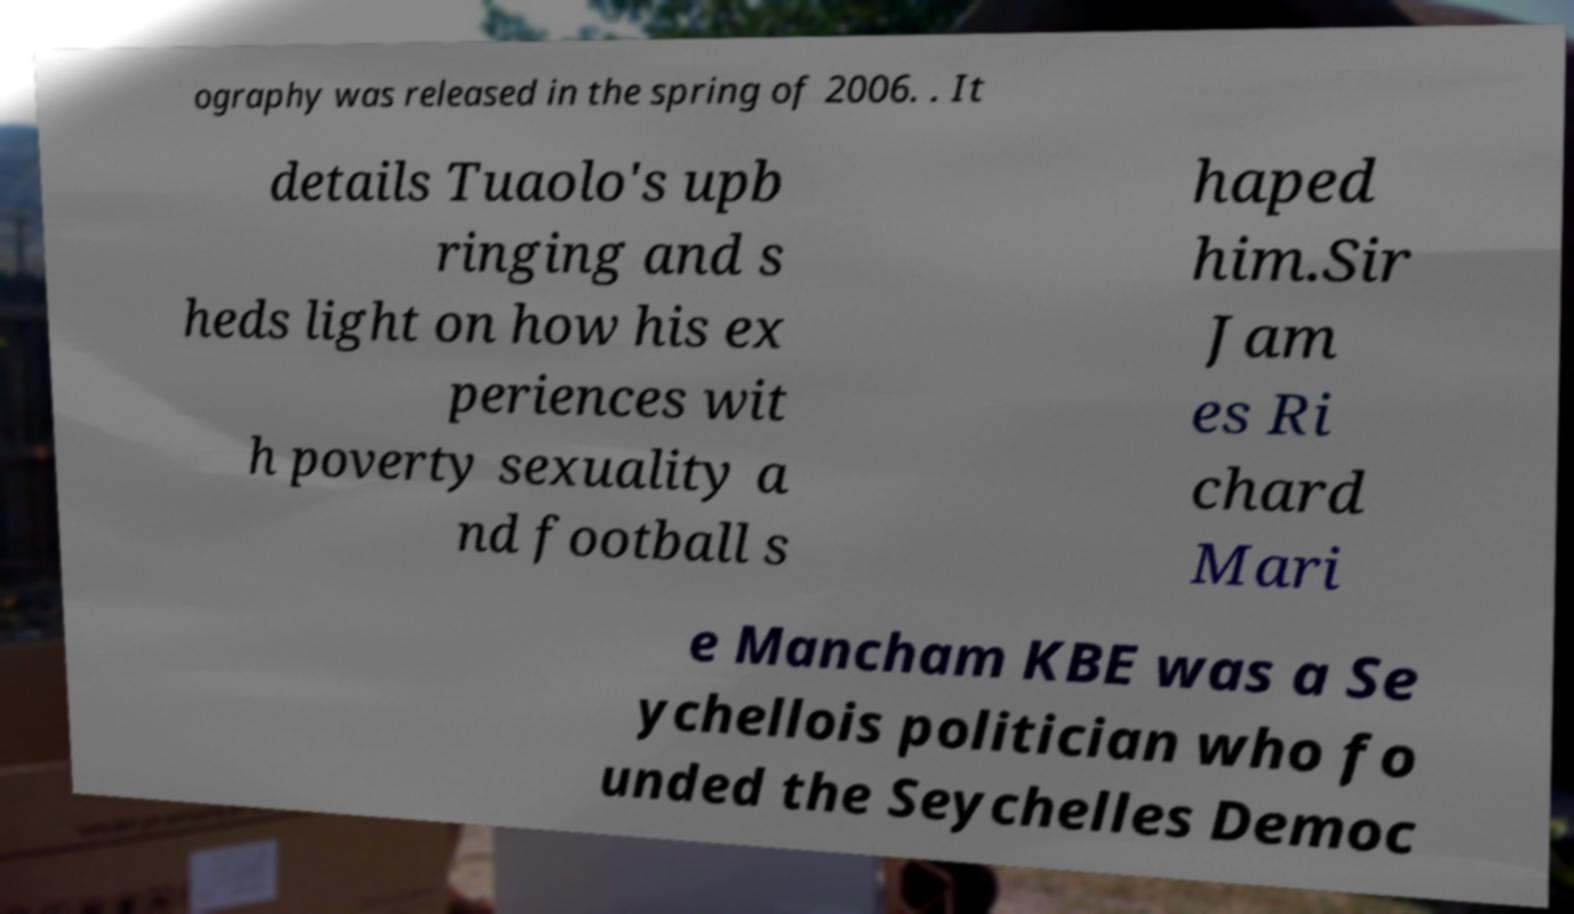For documentation purposes, I need the text within this image transcribed. Could you provide that? ography was released in the spring of 2006. . It details Tuaolo's upb ringing and s heds light on how his ex periences wit h poverty sexuality a nd football s haped him.Sir Jam es Ri chard Mari e Mancham KBE was a Se ychellois politician who fo unded the Seychelles Democ 